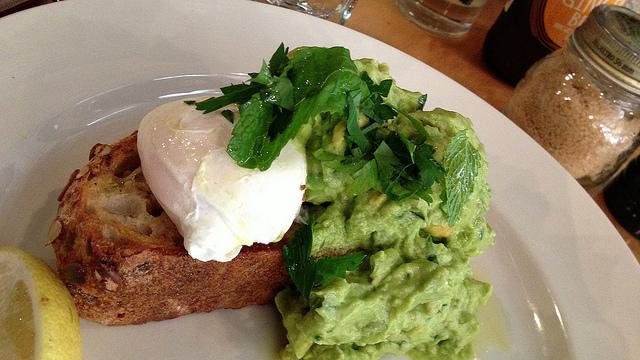Is there a fruit on the plate?
Short answer required. Yes. Will this be a filling meal?
Be succinct. Yes. What is in the plate?
Keep it brief. Food. 